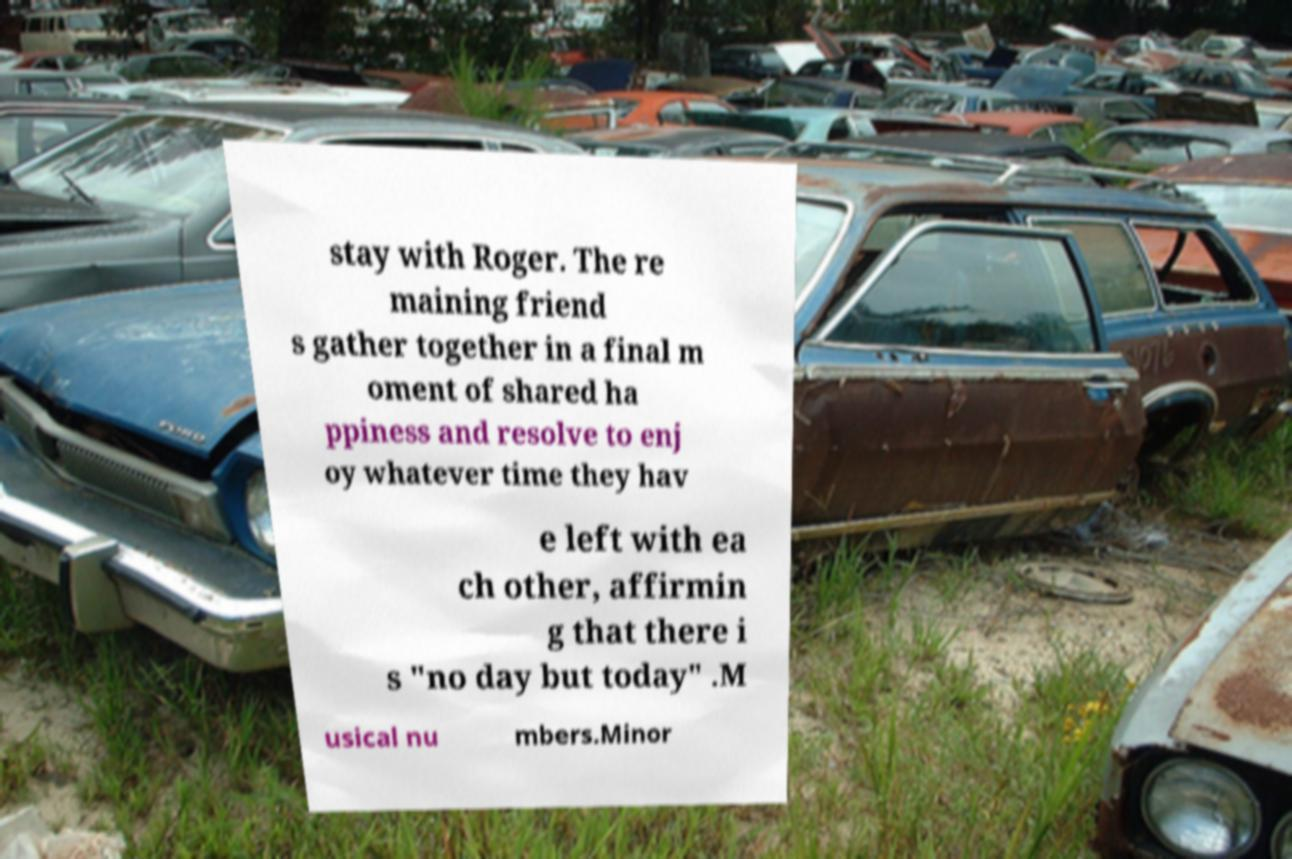What messages or text are displayed in this image? I need them in a readable, typed format. stay with Roger. The re maining friend s gather together in a final m oment of shared ha ppiness and resolve to enj oy whatever time they hav e left with ea ch other, affirmin g that there i s "no day but today" .M usical nu mbers.Minor 